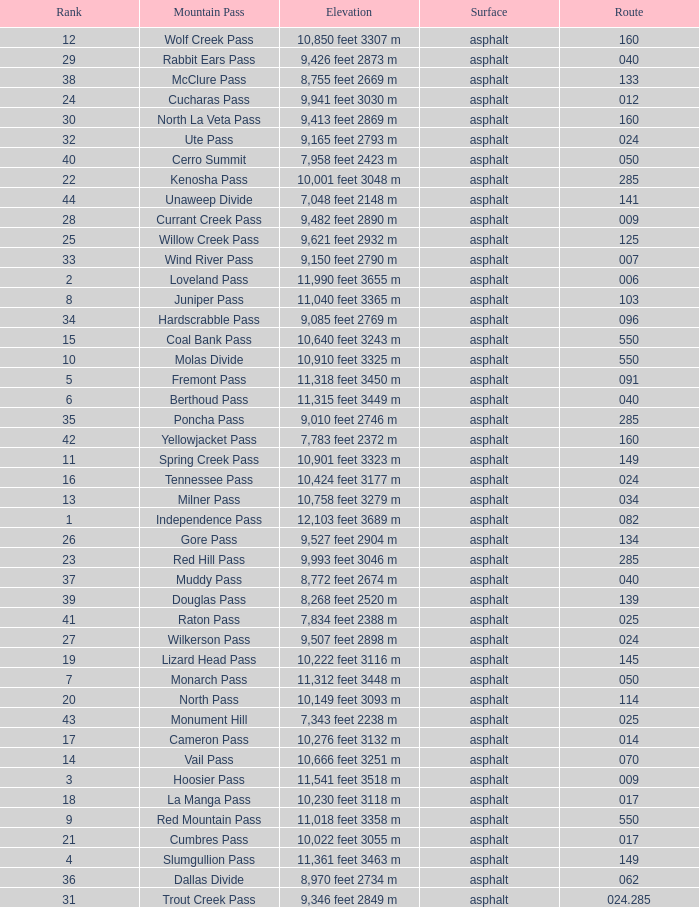Parse the table in full. {'header': ['Rank', 'Mountain Pass', 'Elevation', 'Surface', 'Route'], 'rows': [['12', 'Wolf Creek Pass', '10,850 feet 3307 m', 'asphalt', '160'], ['29', 'Rabbit Ears Pass', '9,426 feet 2873 m', 'asphalt', '040'], ['38', 'McClure Pass', '8,755 feet 2669 m', 'asphalt', '133'], ['24', 'Cucharas Pass', '9,941 feet 3030 m', 'asphalt', '012'], ['30', 'North La Veta Pass', '9,413 feet 2869 m', 'asphalt', '160'], ['32', 'Ute Pass', '9,165 feet 2793 m', 'asphalt', '024'], ['40', 'Cerro Summit', '7,958 feet 2423 m', 'asphalt', '050'], ['22', 'Kenosha Pass', '10,001 feet 3048 m', 'asphalt', '285'], ['44', 'Unaweep Divide', '7,048 feet 2148 m', 'asphalt', '141'], ['28', 'Currant Creek Pass', '9,482 feet 2890 m', 'asphalt', '009'], ['25', 'Willow Creek Pass', '9,621 feet 2932 m', 'asphalt', '125'], ['33', 'Wind River Pass', '9,150 feet 2790 m', 'asphalt', '007'], ['2', 'Loveland Pass', '11,990 feet 3655 m', 'asphalt', '006'], ['8', 'Juniper Pass', '11,040 feet 3365 m', 'asphalt', '103'], ['34', 'Hardscrabble Pass', '9,085 feet 2769 m', 'asphalt', '096'], ['15', 'Coal Bank Pass', '10,640 feet 3243 m', 'asphalt', '550'], ['10', 'Molas Divide', '10,910 feet 3325 m', 'asphalt', '550'], ['5', 'Fremont Pass', '11,318 feet 3450 m', 'asphalt', '091'], ['6', 'Berthoud Pass', '11,315 feet 3449 m', 'asphalt', '040'], ['35', 'Poncha Pass', '9,010 feet 2746 m', 'asphalt', '285'], ['42', 'Yellowjacket Pass', '7,783 feet 2372 m', 'asphalt', '160'], ['11', 'Spring Creek Pass', '10,901 feet 3323 m', 'asphalt', '149'], ['16', 'Tennessee Pass', '10,424 feet 3177 m', 'asphalt', '024'], ['13', 'Milner Pass', '10,758 feet 3279 m', 'asphalt', '034'], ['1', 'Independence Pass', '12,103 feet 3689 m', 'asphalt', '082'], ['26', 'Gore Pass', '9,527 feet 2904 m', 'asphalt', '134'], ['23', 'Red Hill Pass', '9,993 feet 3046 m', 'asphalt', '285'], ['37', 'Muddy Pass', '8,772 feet 2674 m', 'asphalt', '040'], ['39', 'Douglas Pass', '8,268 feet 2520 m', 'asphalt', '139'], ['41', 'Raton Pass', '7,834 feet 2388 m', 'asphalt', '025'], ['27', 'Wilkerson Pass', '9,507 feet 2898 m', 'asphalt', '024'], ['19', 'Lizard Head Pass', '10,222 feet 3116 m', 'asphalt', '145'], ['7', 'Monarch Pass', '11,312 feet 3448 m', 'asphalt', '050'], ['20', 'North Pass', '10,149 feet 3093 m', 'asphalt', '114'], ['43', 'Monument Hill', '7,343 feet 2238 m', 'asphalt', '025'], ['17', 'Cameron Pass', '10,276 feet 3132 m', 'asphalt', '014'], ['14', 'Vail Pass', '10,666 feet 3251 m', 'asphalt', '070'], ['3', 'Hoosier Pass', '11,541 feet 3518 m', 'asphalt', '009'], ['18', 'La Manga Pass', '10,230 feet 3118 m', 'asphalt', '017'], ['9', 'Red Mountain Pass', '11,018 feet 3358 m', 'asphalt', '550'], ['21', 'Cumbres Pass', '10,022 feet 3055 m', 'asphalt', '017'], ['4', 'Slumgullion Pass', '11,361 feet 3463 m', 'asphalt', '149'], ['36', 'Dallas Divide', '8,970 feet 2734 m', 'asphalt', '062'], ['31', 'Trout Creek Pass', '9,346 feet 2849 m', 'asphalt', '024.285']]} Which route includes a mountain with a rank lower than 33 and a height of 11,312 feet (3448 meters)? 50.0. 